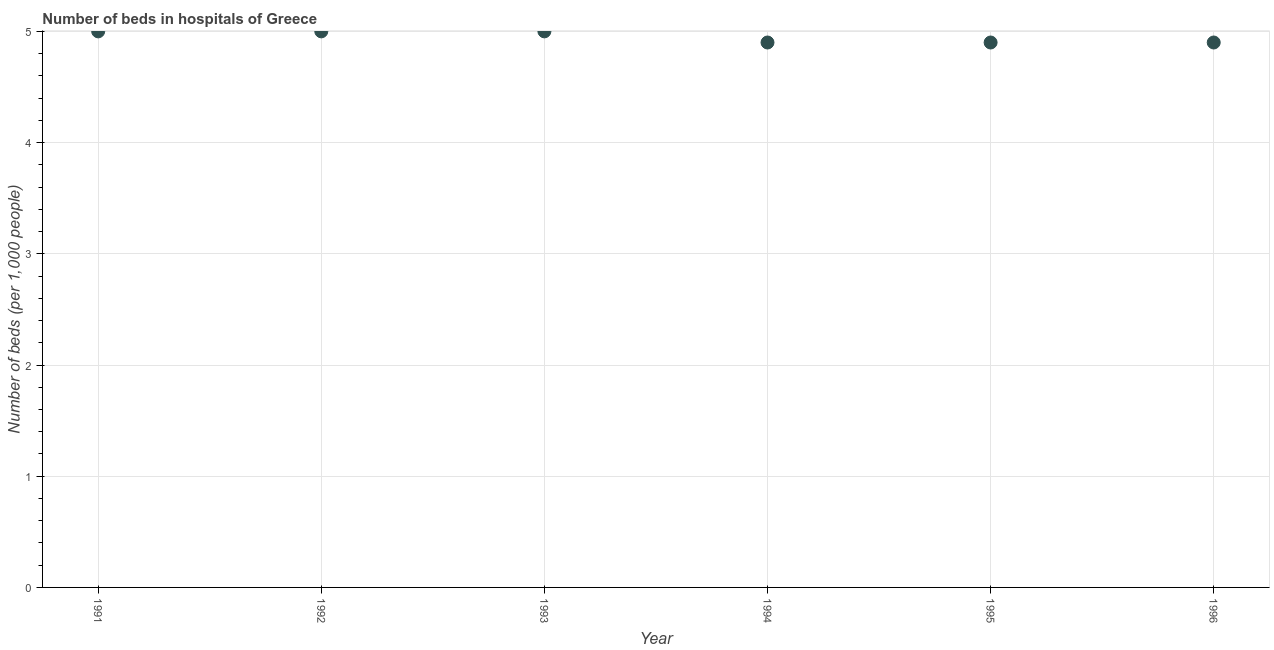What is the number of hospital beds in 1991?
Your answer should be compact. 5. Across all years, what is the minimum number of hospital beds?
Your answer should be compact. 4.9. What is the sum of the number of hospital beds?
Your answer should be compact. 29.7. What is the difference between the number of hospital beds in 1993 and 1996?
Your response must be concise. 0.1. What is the average number of hospital beds per year?
Your answer should be very brief. 4.95. What is the median number of hospital beds?
Provide a short and direct response. 4.95. In how many years, is the number of hospital beds greater than 0.6000000000000001 %?
Offer a very short reply. 6. Do a majority of the years between 1992 and 1996 (inclusive) have number of hospital beds greater than 4.8 %?
Ensure brevity in your answer.  Yes. What is the ratio of the number of hospital beds in 1991 to that in 1993?
Your answer should be compact. 1. Is the number of hospital beds in 1992 less than that in 1996?
Make the answer very short. No. What is the difference between the highest and the second highest number of hospital beds?
Your answer should be very brief. 0. What is the difference between the highest and the lowest number of hospital beds?
Provide a short and direct response. 0.1. Does the graph contain any zero values?
Your response must be concise. No. What is the title of the graph?
Your answer should be compact. Number of beds in hospitals of Greece. What is the label or title of the X-axis?
Provide a succinct answer. Year. What is the label or title of the Y-axis?
Provide a succinct answer. Number of beds (per 1,0 people). What is the Number of beds (per 1,000 people) in 1992?
Your answer should be compact. 5. What is the Number of beds (per 1,000 people) in 1993?
Ensure brevity in your answer.  5. What is the Number of beds (per 1,000 people) in 1994?
Your answer should be compact. 4.9. What is the Number of beds (per 1,000 people) in 1995?
Give a very brief answer. 4.9. What is the Number of beds (per 1,000 people) in 1996?
Provide a succinct answer. 4.9. What is the difference between the Number of beds (per 1,000 people) in 1991 and 1995?
Your answer should be very brief. 0.1. What is the difference between the Number of beds (per 1,000 people) in 1992 and 1994?
Your response must be concise. 0.1. What is the difference between the Number of beds (per 1,000 people) in 1992 and 1995?
Provide a succinct answer. 0.1. What is the difference between the Number of beds (per 1,000 people) in 1992 and 1996?
Keep it short and to the point. 0.1. What is the difference between the Number of beds (per 1,000 people) in 1993 and 1994?
Give a very brief answer. 0.1. What is the difference between the Number of beds (per 1,000 people) in 1993 and 1995?
Keep it short and to the point. 0.1. What is the difference between the Number of beds (per 1,000 people) in 1994 and 1995?
Offer a very short reply. 0. What is the ratio of the Number of beds (per 1,000 people) in 1991 to that in 1992?
Provide a succinct answer. 1. What is the ratio of the Number of beds (per 1,000 people) in 1991 to that in 1993?
Make the answer very short. 1. What is the ratio of the Number of beds (per 1,000 people) in 1991 to that in 1995?
Provide a succinct answer. 1.02. What is the ratio of the Number of beds (per 1,000 people) in 1991 to that in 1996?
Make the answer very short. 1.02. What is the ratio of the Number of beds (per 1,000 people) in 1992 to that in 1993?
Your answer should be very brief. 1. What is the ratio of the Number of beds (per 1,000 people) in 1993 to that in 1995?
Offer a terse response. 1.02. What is the ratio of the Number of beds (per 1,000 people) in 1993 to that in 1996?
Ensure brevity in your answer.  1.02. What is the ratio of the Number of beds (per 1,000 people) in 1994 to that in 1995?
Provide a succinct answer. 1. What is the ratio of the Number of beds (per 1,000 people) in 1994 to that in 1996?
Offer a terse response. 1. 